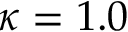Convert formula to latex. <formula><loc_0><loc_0><loc_500><loc_500>\kappa = 1 . 0</formula> 